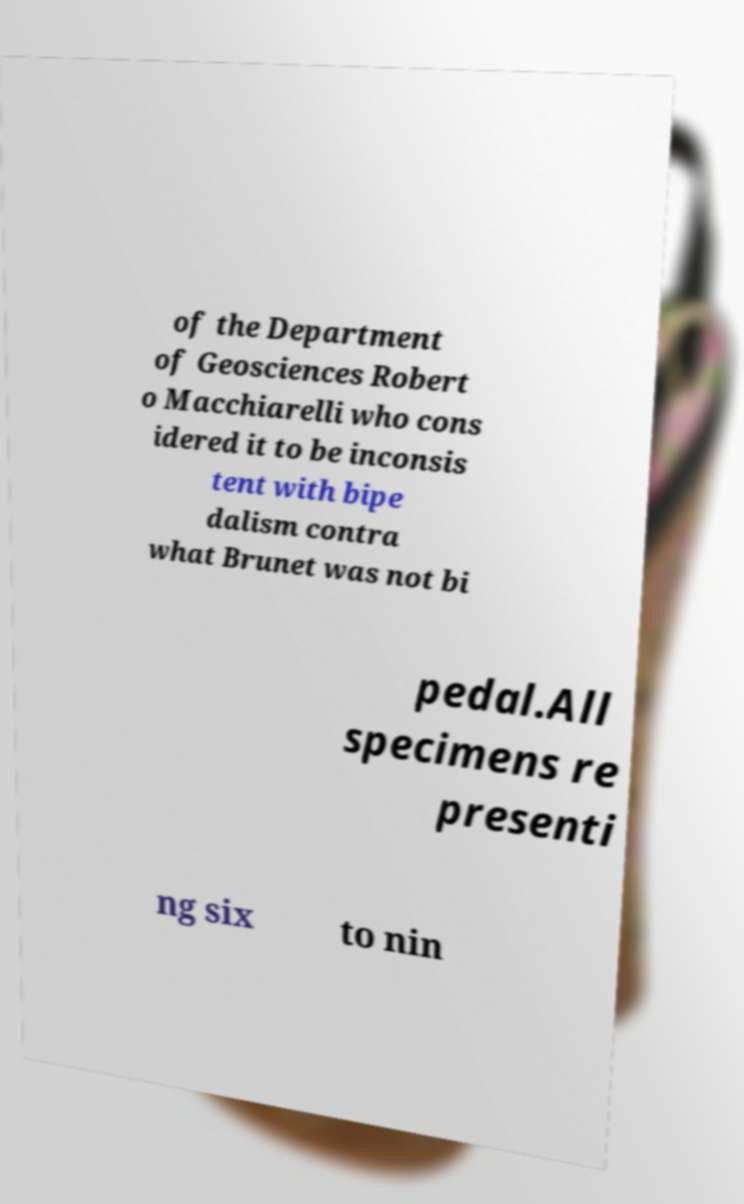What messages or text are displayed in this image? I need them in a readable, typed format. of the Department of Geosciences Robert o Macchiarelli who cons idered it to be inconsis tent with bipe dalism contra what Brunet was not bi pedal.All specimens re presenti ng six to nin 